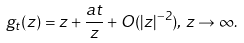<formula> <loc_0><loc_0><loc_500><loc_500>g _ { t } ( z ) = z + \frac { a t } { z } + O ( | z | ^ { - 2 } ) , \, z \rightarrow \infty .</formula> 